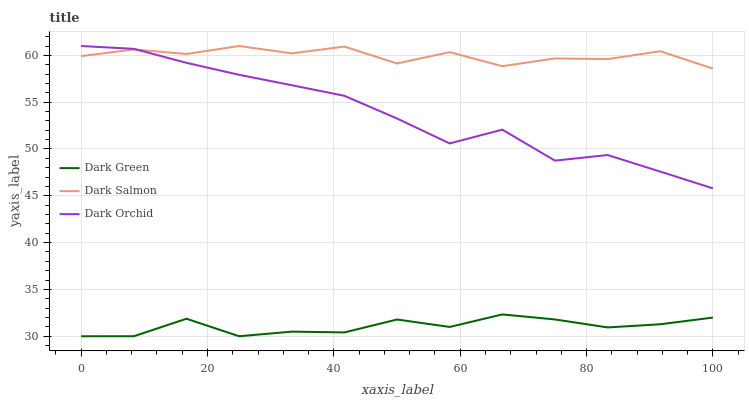Does Dark Green have the minimum area under the curve?
Answer yes or no. Yes. Does Dark Orchid have the minimum area under the curve?
Answer yes or no. No. Does Dark Orchid have the maximum area under the curve?
Answer yes or no. No. Is Dark Salmon the roughest?
Answer yes or no. Yes. Is Dark Orchid the smoothest?
Answer yes or no. No. Is Dark Orchid the roughest?
Answer yes or no. No. Does Dark Orchid have the lowest value?
Answer yes or no. No. Does Dark Green have the highest value?
Answer yes or no. No. Is Dark Green less than Dark Orchid?
Answer yes or no. Yes. Is Dark Salmon greater than Dark Green?
Answer yes or no. Yes. Does Dark Green intersect Dark Orchid?
Answer yes or no. No. 